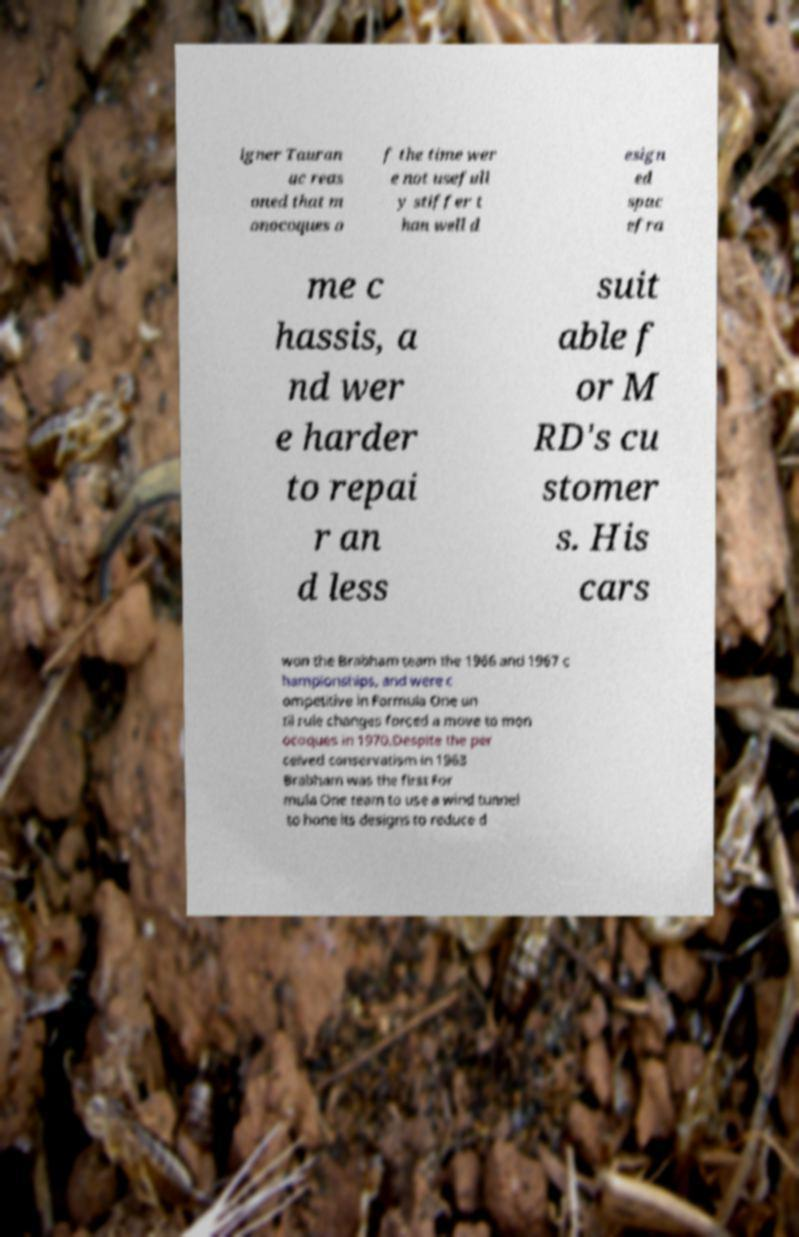Can you accurately transcribe the text from the provided image for me? igner Tauran ac reas oned that m onocoques o f the time wer e not usefull y stiffer t han well d esign ed spac efra me c hassis, a nd wer e harder to repai r an d less suit able f or M RD's cu stomer s. His cars won the Brabham team the 1966 and 1967 c hampionships, and were c ompetitive in Formula One un til rule changes forced a move to mon ocoques in 1970.Despite the per ceived conservatism in 1963 Brabham was the first For mula One team to use a wind tunnel to hone its designs to reduce d 